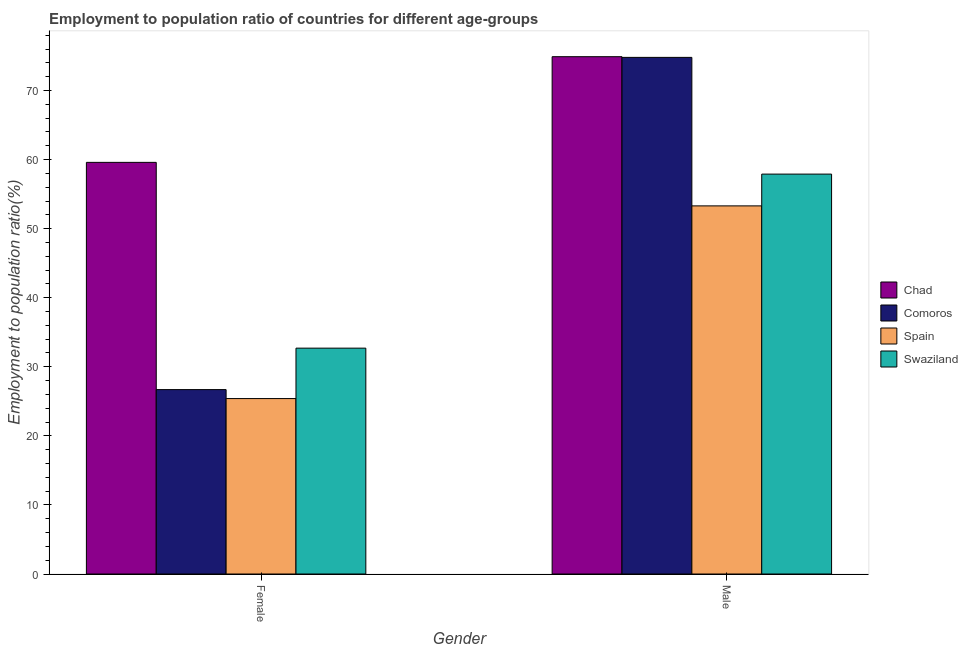How many different coloured bars are there?
Provide a succinct answer. 4. How many groups of bars are there?
Your response must be concise. 2. How many bars are there on the 1st tick from the right?
Your answer should be very brief. 4. What is the employment to population ratio(male) in Swaziland?
Offer a very short reply. 57.9. Across all countries, what is the maximum employment to population ratio(male)?
Give a very brief answer. 74.9. Across all countries, what is the minimum employment to population ratio(male)?
Your response must be concise. 53.3. In which country was the employment to population ratio(male) maximum?
Your answer should be compact. Chad. In which country was the employment to population ratio(male) minimum?
Your answer should be compact. Spain. What is the total employment to population ratio(male) in the graph?
Provide a succinct answer. 260.9. What is the difference between the employment to population ratio(male) in Chad and that in Comoros?
Provide a short and direct response. 0.1. What is the difference between the employment to population ratio(female) in Chad and the employment to population ratio(male) in Comoros?
Offer a very short reply. -15.2. What is the average employment to population ratio(male) per country?
Make the answer very short. 65.23. What is the difference between the employment to population ratio(male) and employment to population ratio(female) in Spain?
Ensure brevity in your answer.  27.9. What is the ratio of the employment to population ratio(female) in Spain to that in Comoros?
Ensure brevity in your answer.  0.95. Is the employment to population ratio(male) in Comoros less than that in Swaziland?
Make the answer very short. No. In how many countries, is the employment to population ratio(male) greater than the average employment to population ratio(male) taken over all countries?
Ensure brevity in your answer.  2. What does the 1st bar from the left in Male represents?
Your answer should be compact. Chad. What does the 1st bar from the right in Male represents?
Keep it short and to the point. Swaziland. How many bars are there?
Ensure brevity in your answer.  8. Are all the bars in the graph horizontal?
Provide a succinct answer. No. What is the difference between two consecutive major ticks on the Y-axis?
Ensure brevity in your answer.  10. Are the values on the major ticks of Y-axis written in scientific E-notation?
Make the answer very short. No. Does the graph contain grids?
Ensure brevity in your answer.  No. What is the title of the graph?
Give a very brief answer. Employment to population ratio of countries for different age-groups. Does "Middle East & North Africa (developing only)" appear as one of the legend labels in the graph?
Provide a succinct answer. No. What is the label or title of the Y-axis?
Provide a short and direct response. Employment to population ratio(%). What is the Employment to population ratio(%) of Chad in Female?
Your answer should be compact. 59.6. What is the Employment to population ratio(%) of Comoros in Female?
Offer a very short reply. 26.7. What is the Employment to population ratio(%) of Spain in Female?
Offer a terse response. 25.4. What is the Employment to population ratio(%) of Swaziland in Female?
Your answer should be very brief. 32.7. What is the Employment to population ratio(%) of Chad in Male?
Make the answer very short. 74.9. What is the Employment to population ratio(%) of Comoros in Male?
Make the answer very short. 74.8. What is the Employment to population ratio(%) in Spain in Male?
Your answer should be very brief. 53.3. What is the Employment to population ratio(%) of Swaziland in Male?
Offer a terse response. 57.9. Across all Gender, what is the maximum Employment to population ratio(%) of Chad?
Provide a short and direct response. 74.9. Across all Gender, what is the maximum Employment to population ratio(%) in Comoros?
Make the answer very short. 74.8. Across all Gender, what is the maximum Employment to population ratio(%) of Spain?
Your answer should be very brief. 53.3. Across all Gender, what is the maximum Employment to population ratio(%) of Swaziland?
Provide a succinct answer. 57.9. Across all Gender, what is the minimum Employment to population ratio(%) in Chad?
Ensure brevity in your answer.  59.6. Across all Gender, what is the minimum Employment to population ratio(%) of Comoros?
Offer a terse response. 26.7. Across all Gender, what is the minimum Employment to population ratio(%) in Spain?
Offer a terse response. 25.4. Across all Gender, what is the minimum Employment to population ratio(%) in Swaziland?
Offer a terse response. 32.7. What is the total Employment to population ratio(%) of Chad in the graph?
Provide a short and direct response. 134.5. What is the total Employment to population ratio(%) in Comoros in the graph?
Your answer should be very brief. 101.5. What is the total Employment to population ratio(%) of Spain in the graph?
Provide a succinct answer. 78.7. What is the total Employment to population ratio(%) in Swaziland in the graph?
Your answer should be compact. 90.6. What is the difference between the Employment to population ratio(%) of Chad in Female and that in Male?
Keep it short and to the point. -15.3. What is the difference between the Employment to population ratio(%) in Comoros in Female and that in Male?
Your response must be concise. -48.1. What is the difference between the Employment to population ratio(%) of Spain in Female and that in Male?
Offer a very short reply. -27.9. What is the difference between the Employment to population ratio(%) of Swaziland in Female and that in Male?
Offer a very short reply. -25.2. What is the difference between the Employment to population ratio(%) in Chad in Female and the Employment to population ratio(%) in Comoros in Male?
Offer a terse response. -15.2. What is the difference between the Employment to population ratio(%) of Chad in Female and the Employment to population ratio(%) of Spain in Male?
Make the answer very short. 6.3. What is the difference between the Employment to population ratio(%) in Chad in Female and the Employment to population ratio(%) in Swaziland in Male?
Keep it short and to the point. 1.7. What is the difference between the Employment to population ratio(%) of Comoros in Female and the Employment to population ratio(%) of Spain in Male?
Offer a very short reply. -26.6. What is the difference between the Employment to population ratio(%) of Comoros in Female and the Employment to population ratio(%) of Swaziland in Male?
Provide a succinct answer. -31.2. What is the difference between the Employment to population ratio(%) in Spain in Female and the Employment to population ratio(%) in Swaziland in Male?
Offer a terse response. -32.5. What is the average Employment to population ratio(%) of Chad per Gender?
Your response must be concise. 67.25. What is the average Employment to population ratio(%) in Comoros per Gender?
Provide a succinct answer. 50.75. What is the average Employment to population ratio(%) in Spain per Gender?
Give a very brief answer. 39.35. What is the average Employment to population ratio(%) of Swaziland per Gender?
Provide a succinct answer. 45.3. What is the difference between the Employment to population ratio(%) in Chad and Employment to population ratio(%) in Comoros in Female?
Give a very brief answer. 32.9. What is the difference between the Employment to population ratio(%) in Chad and Employment to population ratio(%) in Spain in Female?
Ensure brevity in your answer.  34.2. What is the difference between the Employment to population ratio(%) in Chad and Employment to population ratio(%) in Swaziland in Female?
Provide a short and direct response. 26.9. What is the difference between the Employment to population ratio(%) in Comoros and Employment to population ratio(%) in Spain in Female?
Give a very brief answer. 1.3. What is the difference between the Employment to population ratio(%) of Comoros and Employment to population ratio(%) of Swaziland in Female?
Make the answer very short. -6. What is the difference between the Employment to population ratio(%) in Spain and Employment to population ratio(%) in Swaziland in Female?
Your response must be concise. -7.3. What is the difference between the Employment to population ratio(%) in Chad and Employment to population ratio(%) in Spain in Male?
Offer a very short reply. 21.6. What is the difference between the Employment to population ratio(%) of Chad and Employment to population ratio(%) of Swaziland in Male?
Give a very brief answer. 17. What is the difference between the Employment to population ratio(%) of Comoros and Employment to population ratio(%) of Spain in Male?
Your response must be concise. 21.5. What is the difference between the Employment to population ratio(%) in Comoros and Employment to population ratio(%) in Swaziland in Male?
Offer a very short reply. 16.9. What is the ratio of the Employment to population ratio(%) in Chad in Female to that in Male?
Make the answer very short. 0.8. What is the ratio of the Employment to population ratio(%) in Comoros in Female to that in Male?
Make the answer very short. 0.36. What is the ratio of the Employment to population ratio(%) of Spain in Female to that in Male?
Offer a very short reply. 0.48. What is the ratio of the Employment to population ratio(%) of Swaziland in Female to that in Male?
Make the answer very short. 0.56. What is the difference between the highest and the second highest Employment to population ratio(%) of Comoros?
Offer a terse response. 48.1. What is the difference between the highest and the second highest Employment to population ratio(%) in Spain?
Your answer should be compact. 27.9. What is the difference between the highest and the second highest Employment to population ratio(%) in Swaziland?
Your response must be concise. 25.2. What is the difference between the highest and the lowest Employment to population ratio(%) in Comoros?
Provide a short and direct response. 48.1. What is the difference between the highest and the lowest Employment to population ratio(%) of Spain?
Your answer should be compact. 27.9. What is the difference between the highest and the lowest Employment to population ratio(%) of Swaziland?
Give a very brief answer. 25.2. 